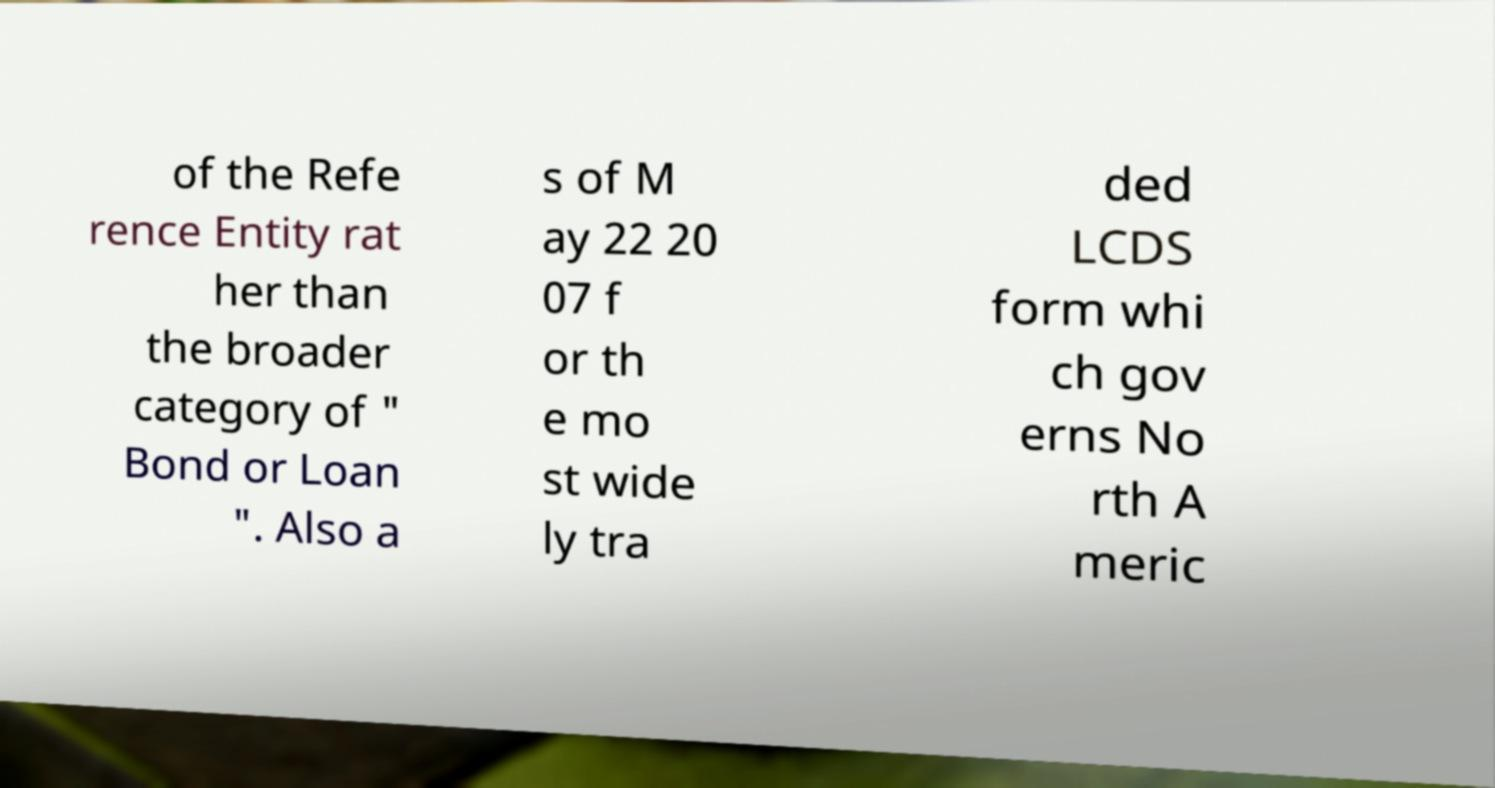Can you read and provide the text displayed in the image?This photo seems to have some interesting text. Can you extract and type it out for me? of the Refe rence Entity rat her than the broader category of " Bond or Loan ". Also a s of M ay 22 20 07 f or th e mo st wide ly tra ded LCDS form whi ch gov erns No rth A meric 